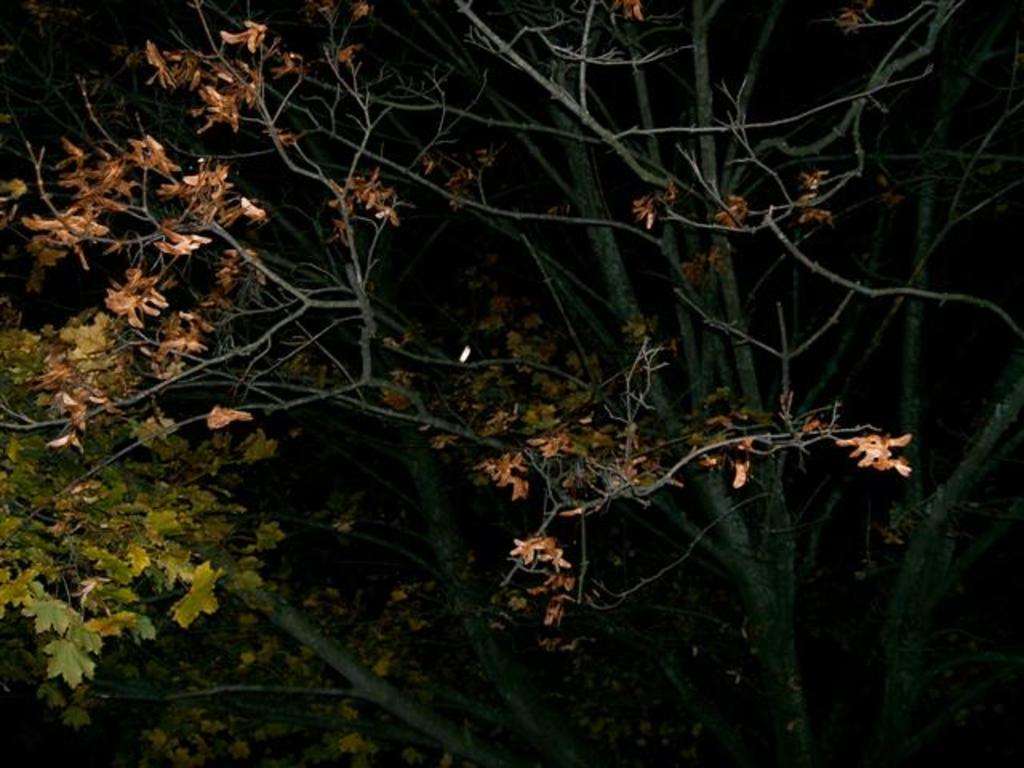What type of vegetation is visible in the image? There are branches of trees in the image. What is the color of the background in the image? The background of the image is dark. What type of toothpaste is being used to jump over the branches in the image? There is no toothpaste or jumping activity present in the image. What type of rod can be seen interacting with the branches in the image? There is no rod present in the image; only the branches of trees are visible. 